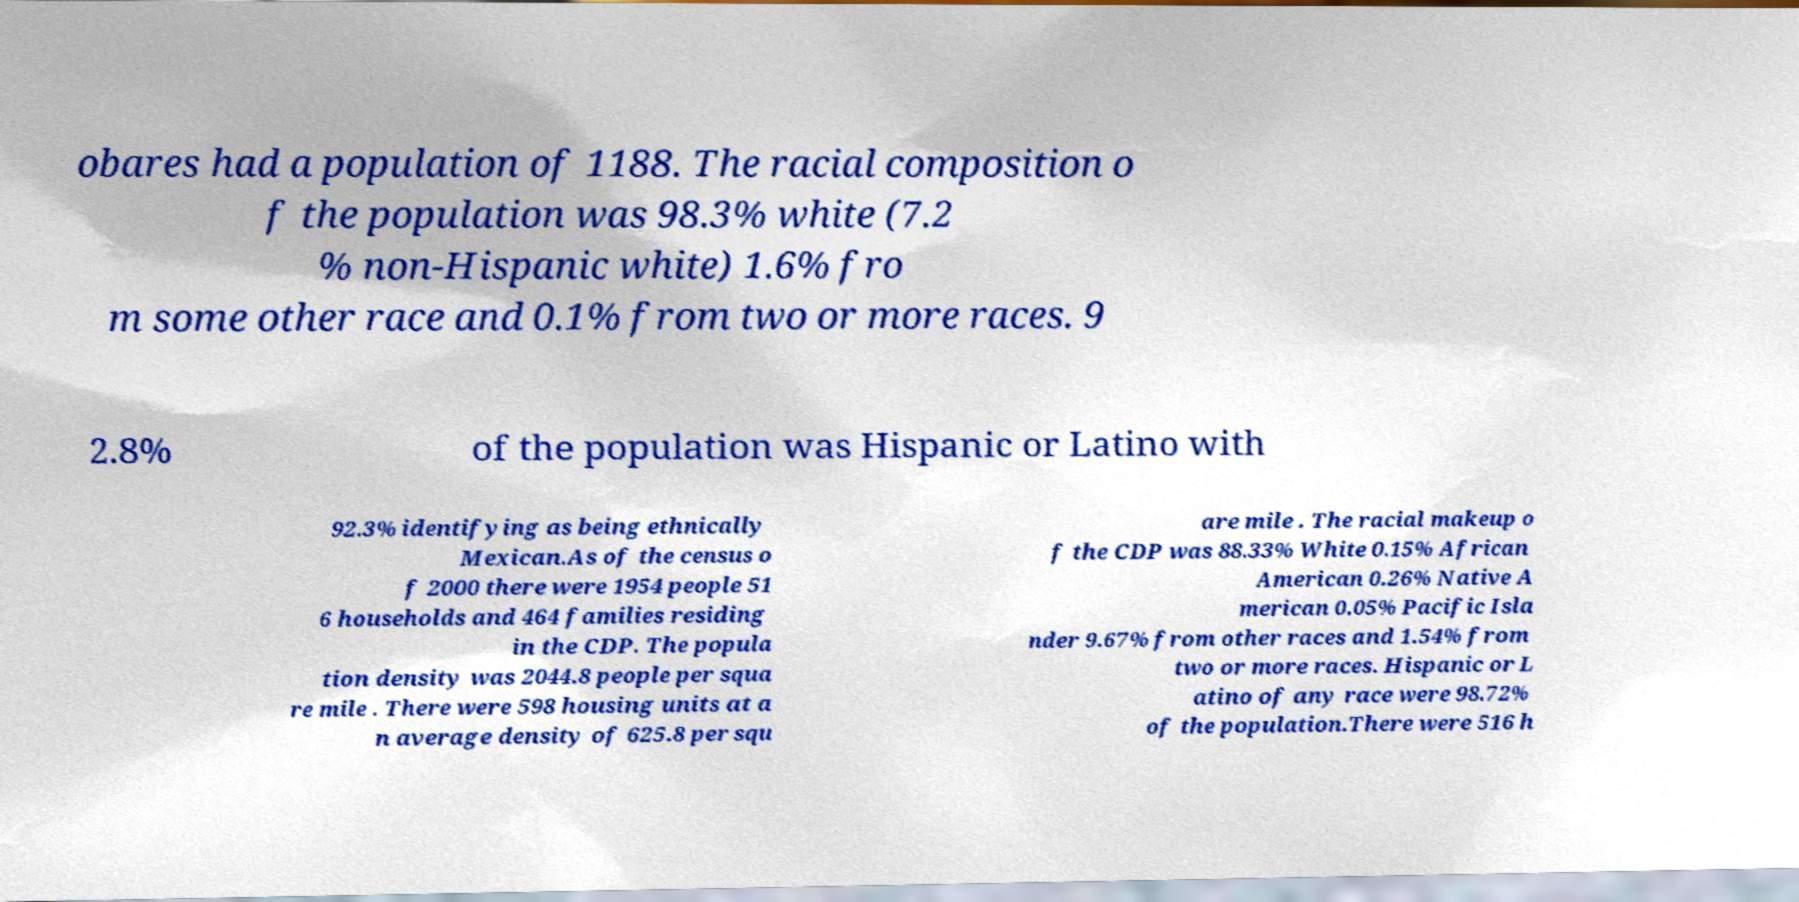Could you assist in decoding the text presented in this image and type it out clearly? obares had a population of 1188. The racial composition o f the population was 98.3% white (7.2 % non-Hispanic white) 1.6% fro m some other race and 0.1% from two or more races. 9 2.8% of the population was Hispanic or Latino with 92.3% identifying as being ethnically Mexican.As of the census o f 2000 there were 1954 people 51 6 households and 464 families residing in the CDP. The popula tion density was 2044.8 people per squa re mile . There were 598 housing units at a n average density of 625.8 per squ are mile . The racial makeup o f the CDP was 88.33% White 0.15% African American 0.26% Native A merican 0.05% Pacific Isla nder 9.67% from other races and 1.54% from two or more races. Hispanic or L atino of any race were 98.72% of the population.There were 516 h 